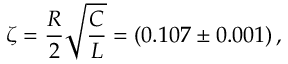Convert formula to latex. <formula><loc_0><loc_0><loc_500><loc_500>\zeta = \frac { R } { 2 } \sqrt { \frac { C } { L } } = ( 0 . 1 0 7 \pm 0 . 0 0 1 ) \, ,</formula> 